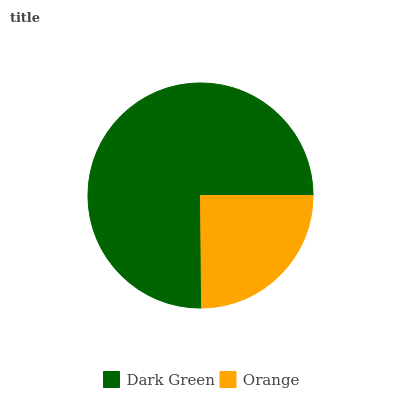Is Orange the minimum?
Answer yes or no. Yes. Is Dark Green the maximum?
Answer yes or no. Yes. Is Orange the maximum?
Answer yes or no. No. Is Dark Green greater than Orange?
Answer yes or no. Yes. Is Orange less than Dark Green?
Answer yes or no. Yes. Is Orange greater than Dark Green?
Answer yes or no. No. Is Dark Green less than Orange?
Answer yes or no. No. Is Dark Green the high median?
Answer yes or no. Yes. Is Orange the low median?
Answer yes or no. Yes. Is Orange the high median?
Answer yes or no. No. Is Dark Green the low median?
Answer yes or no. No. 